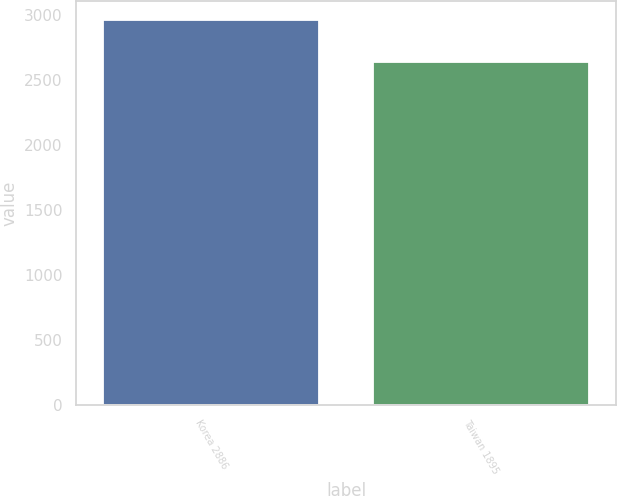Convert chart to OTSL. <chart><loc_0><loc_0><loc_500><loc_500><bar_chart><fcel>Korea 2886<fcel>Taiwan 1895<nl><fcel>2962<fcel>2638<nl></chart> 